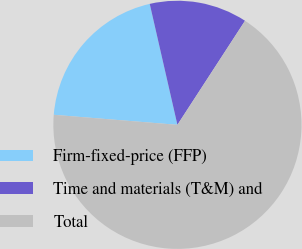Convert chart. <chart><loc_0><loc_0><loc_500><loc_500><pie_chart><fcel>Firm-fixed-price (FFP)<fcel>Time and materials (T&M) and<fcel>Total<nl><fcel>20.13%<fcel>12.75%<fcel>67.11%<nl></chart> 